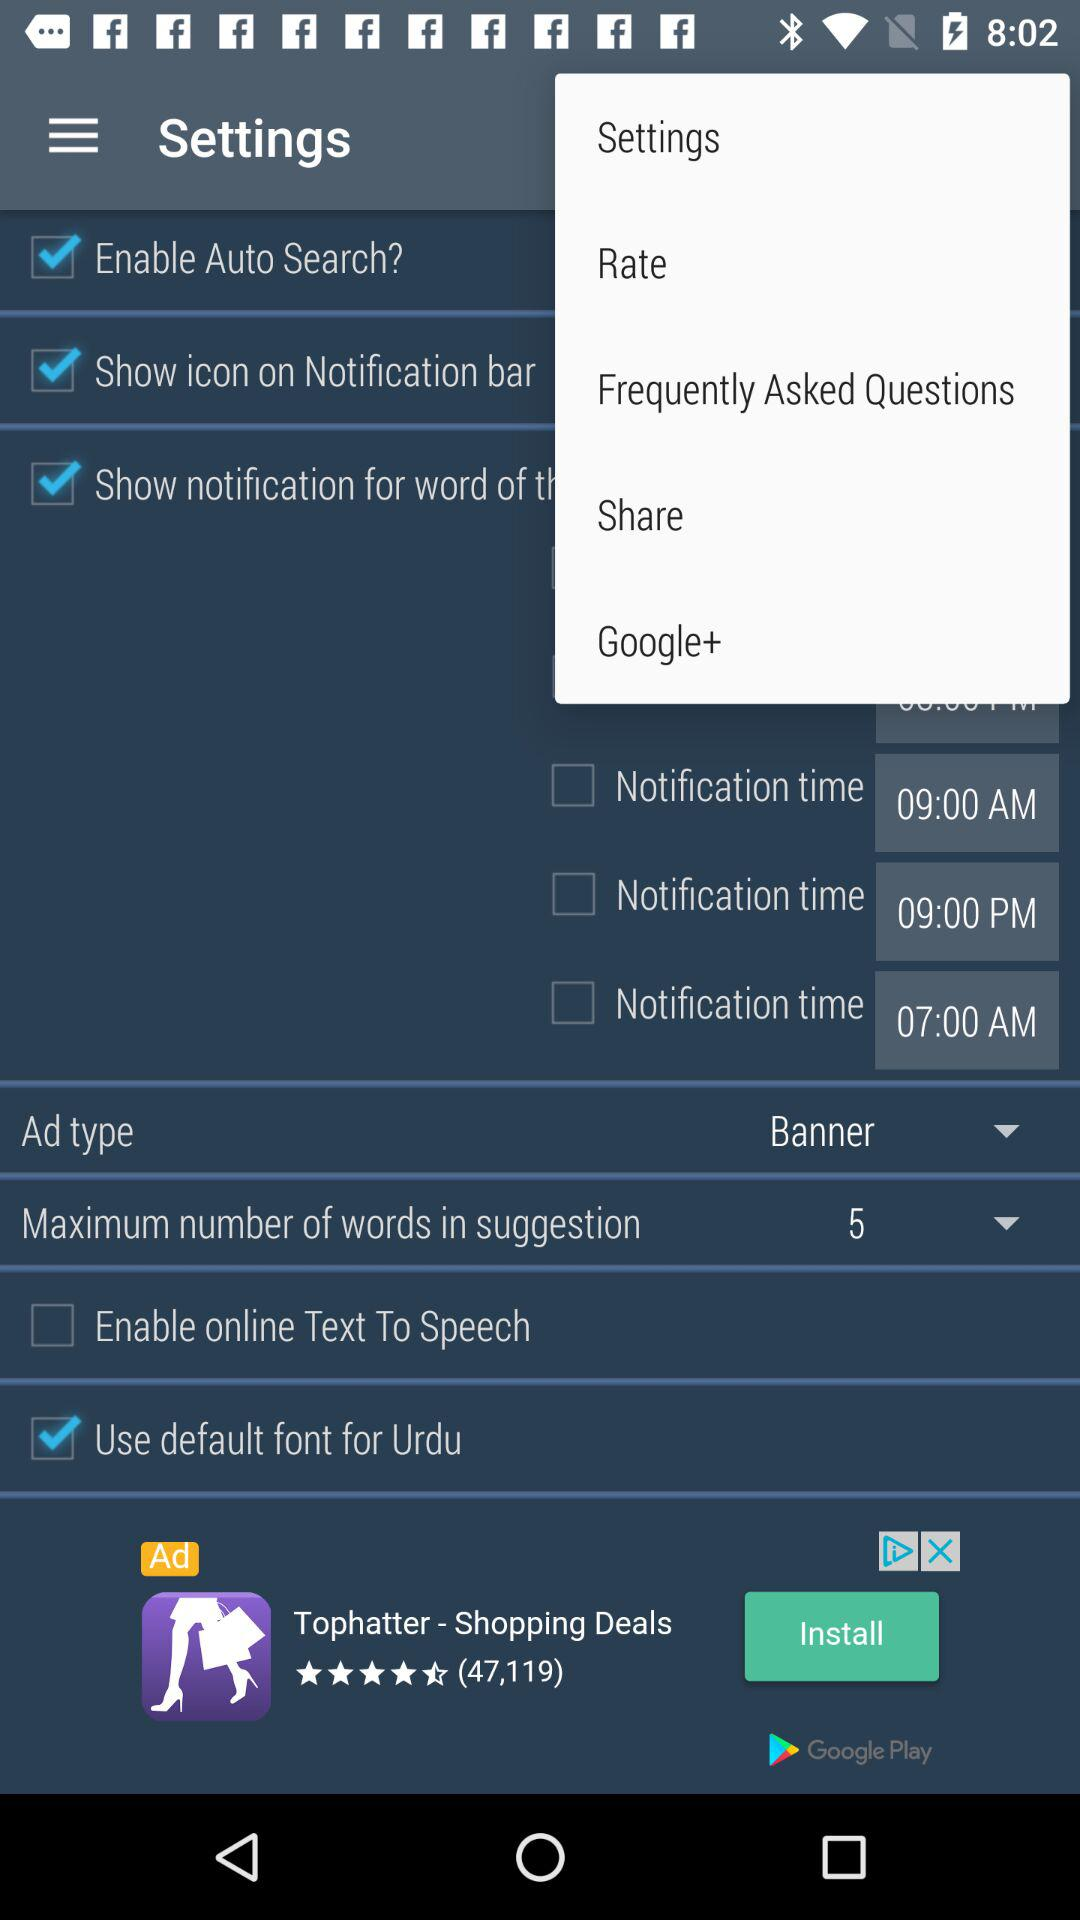Is "Use default font for Urdu" selected or not? It is "not selected". 